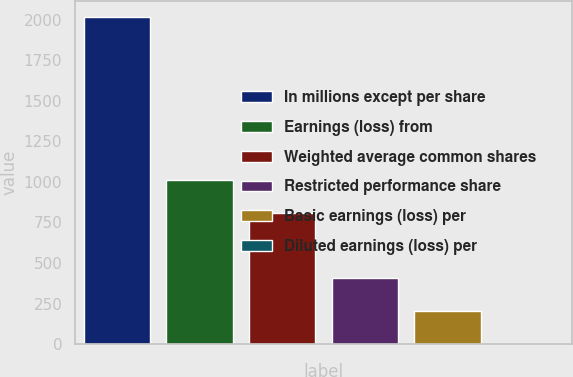<chart> <loc_0><loc_0><loc_500><loc_500><bar_chart><fcel>In millions except per share<fcel>Earnings (loss) from<fcel>Weighted average common shares<fcel>Restricted performance share<fcel>Basic earnings (loss) per<fcel>Diluted earnings (loss) per<nl><fcel>2016<fcel>1008.98<fcel>807.57<fcel>404.75<fcel>203.34<fcel>1.93<nl></chart> 